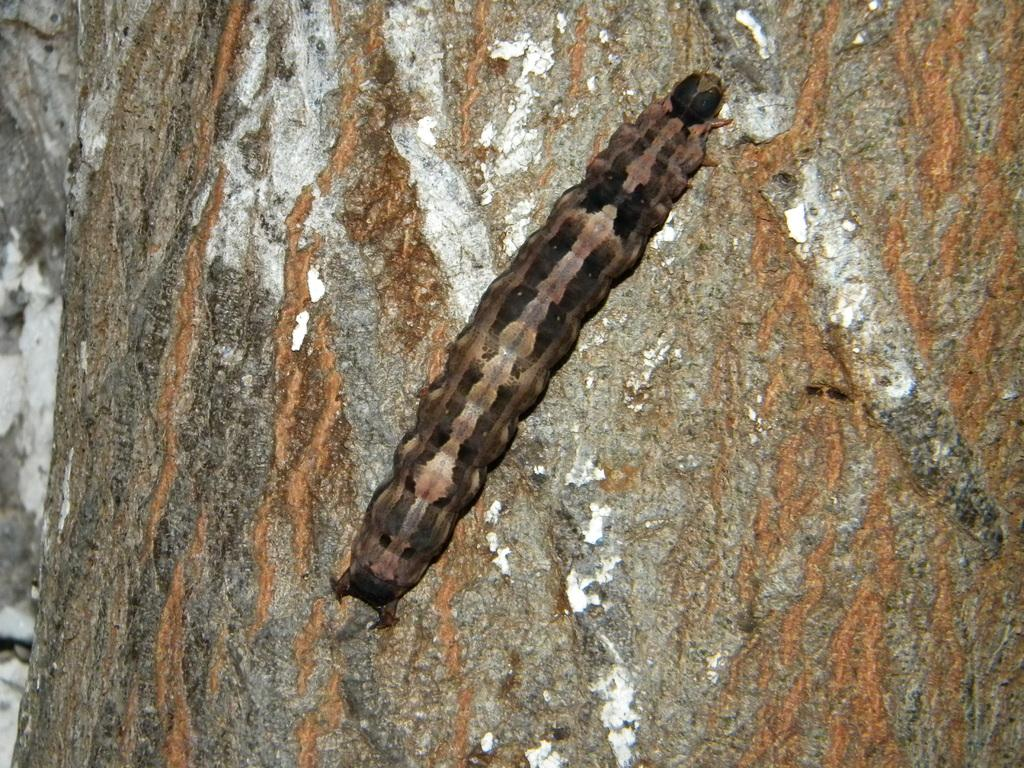What type of creature can be seen in the image? There is an insect in the image. Where is the insect located? The insect is on a tree trunk. What type of leaf is the insect holding in the image? There is no leaf present in the image, and the insect is not holding anything. 